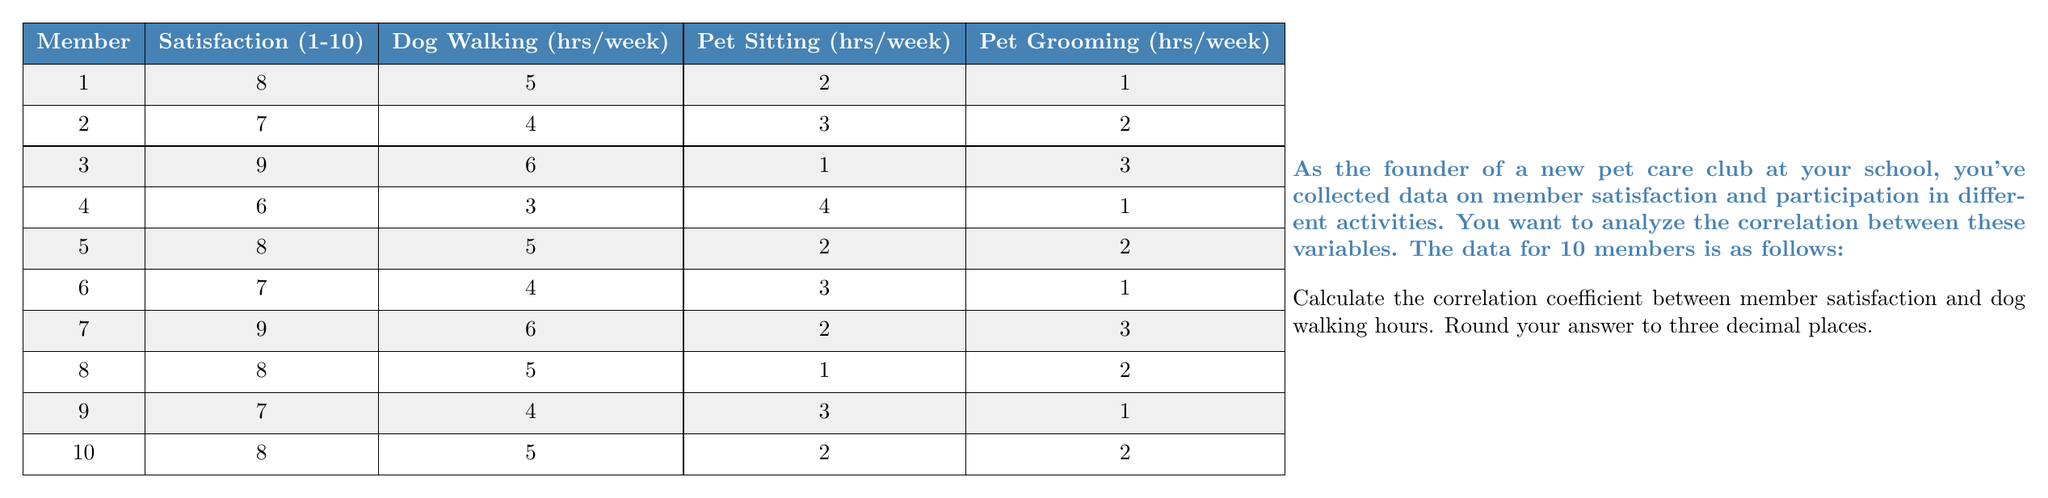Can you solve this math problem? To calculate the correlation coefficient between member satisfaction and dog walking hours, we'll use the Pearson correlation coefficient formula:

$$ r = \frac{\sum_{i=1}^{n} (x_i - \bar{x})(y_i - \bar{y})}{\sqrt{\sum_{i=1}^{n} (x_i - \bar{x})^2 \sum_{i=1}^{n} (y_i - \bar{y})^2}} $$

Where:
$x_i$ = satisfaction scores
$y_i$ = dog walking hours
$\bar{x}$ = mean satisfaction score
$\bar{y}$ = mean dog walking hours
$n$ = number of members (10)

Step 1: Calculate means
$\bar{x} = \frac{8 + 7 + 9 + 6 + 8 + 7 + 9 + 8 + 7 + 8}{10} = 7.7$
$\bar{y} = \frac{5 + 4 + 6 + 3 + 5 + 4 + 6 + 5 + 4 + 5}{10} = 4.7$

Step 2: Calculate $(x_i - \bar{x})$, $(y_i - \bar{y})$, $(x_i - \bar{x})^2$, $(y_i - \bar{y})^2$, and $(x_i - \bar{x})(y_i - \bar{y})$ for each member.

Step 3: Sum the calculated values:
$\sum (x_i - \bar{x})(y_i - \bar{y}) = 5.1$
$\sum (x_i - \bar{x})^2 = 7.1$
$\sum (y_i - \bar{y})^2 = 6.1$

Step 4: Apply the formula:

$$ r = \frac{5.1}{\sqrt{7.1 \times 6.1}} = \frac{5.1}{\sqrt{43.31}} = \frac{5.1}{6.581} = 0.775 $$

Rounding to three decimal places: 0.775
Answer: 0.775 